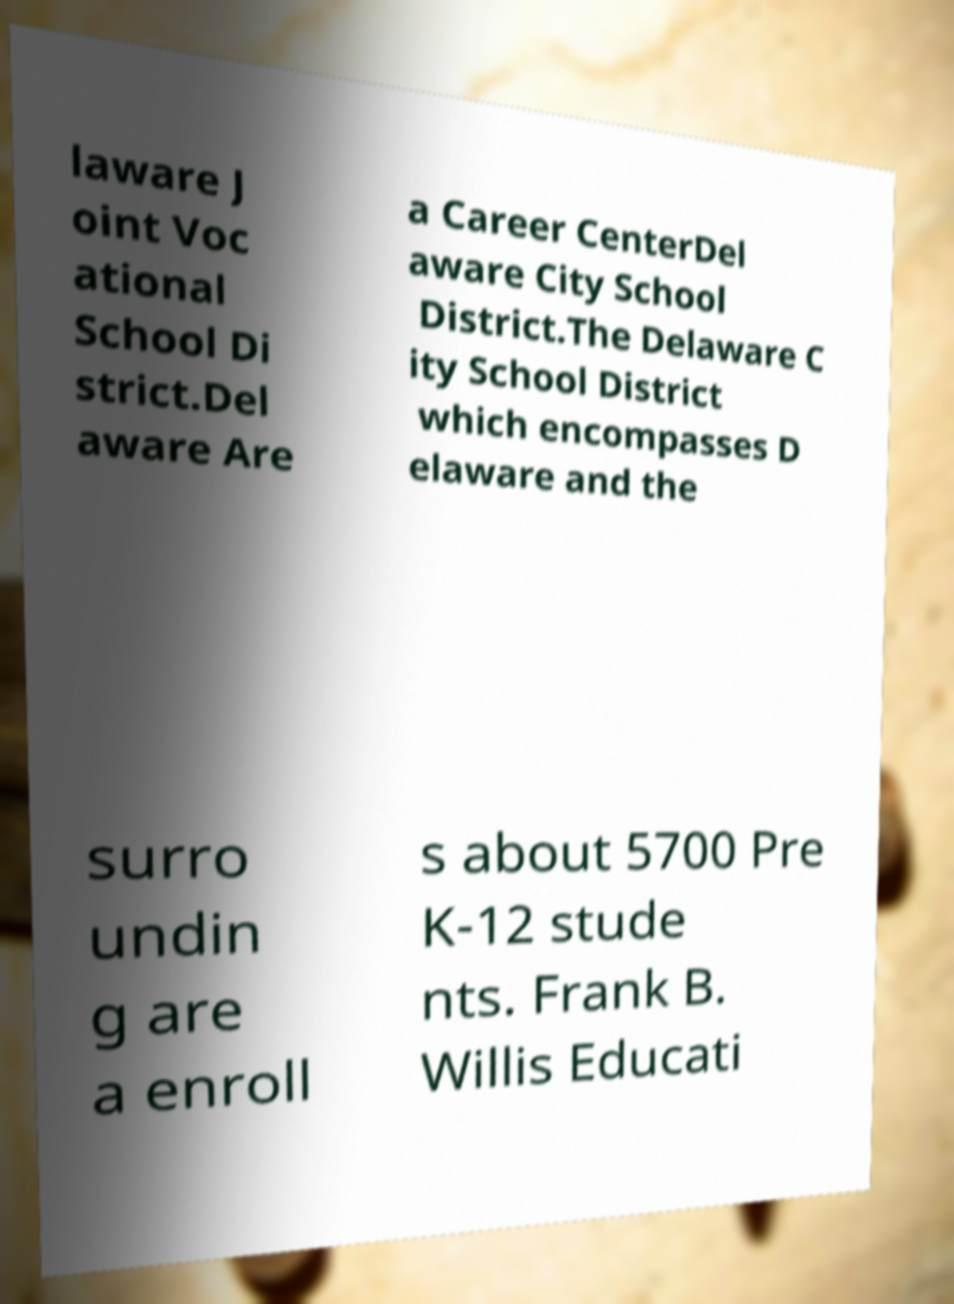Can you accurately transcribe the text from the provided image for me? laware J oint Voc ational School Di strict.Del aware Are a Career CenterDel aware City School District.The Delaware C ity School District which encompasses D elaware and the surro undin g are a enroll s about 5700 Pre K-12 stude nts. Frank B. Willis Educati 